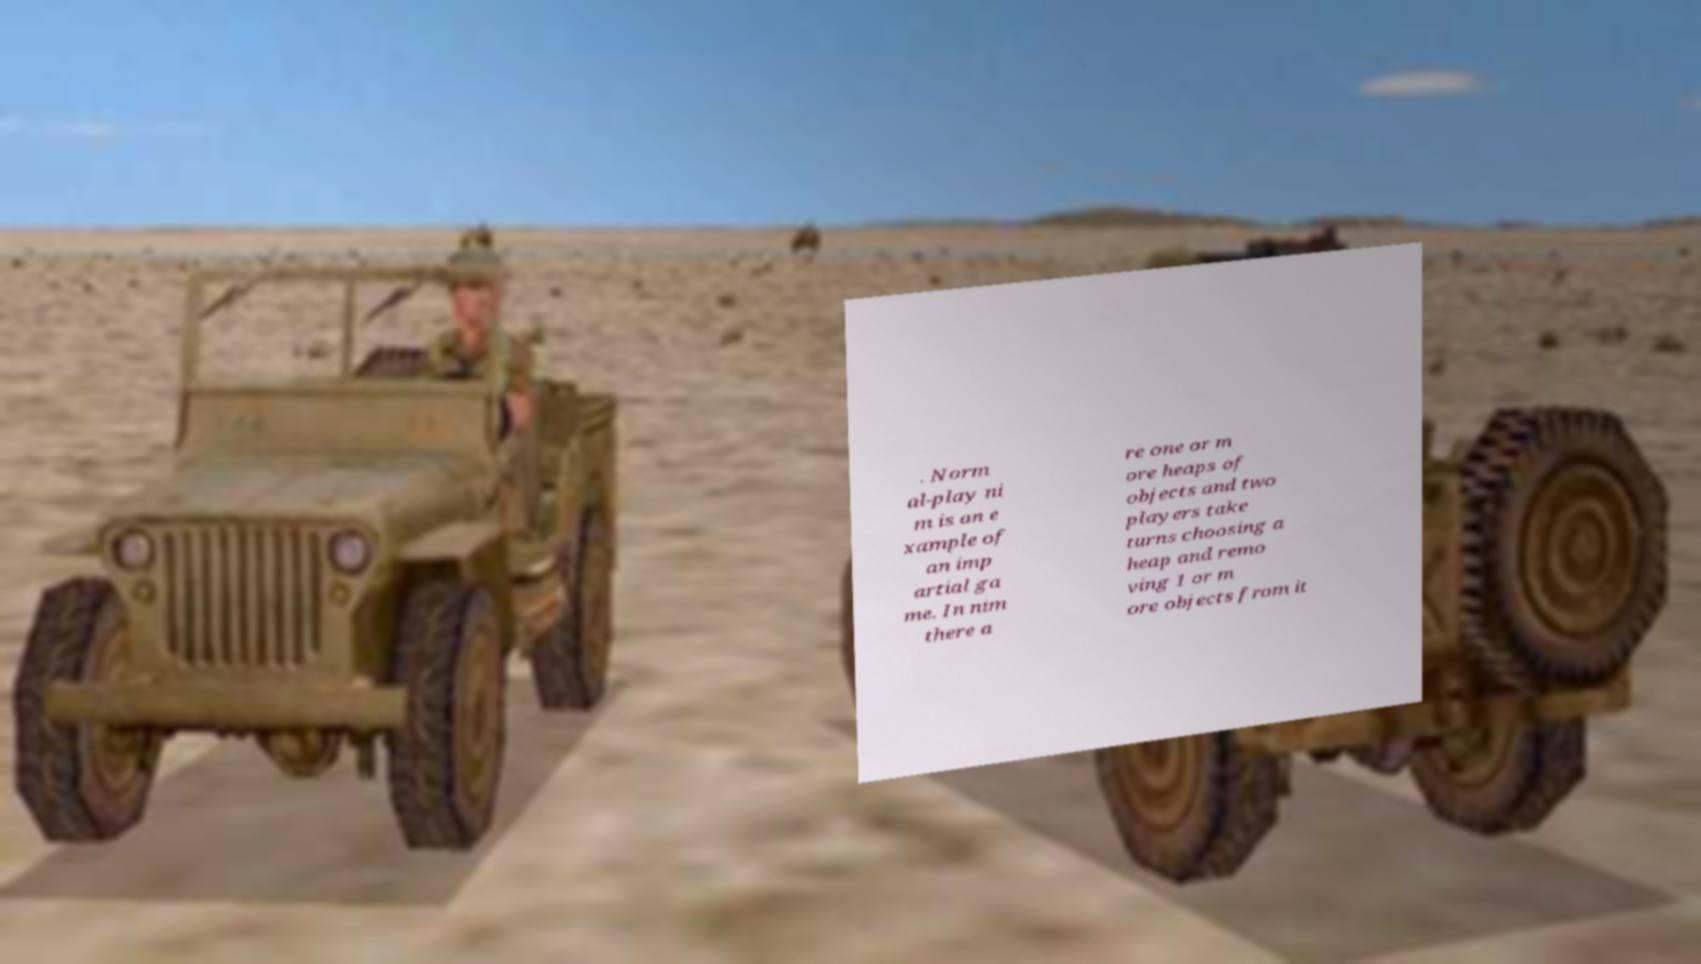Please identify and transcribe the text found in this image. . Norm al-play ni m is an e xample of an imp artial ga me. In nim there a re one or m ore heaps of objects and two players take turns choosing a heap and remo ving 1 or m ore objects from it 